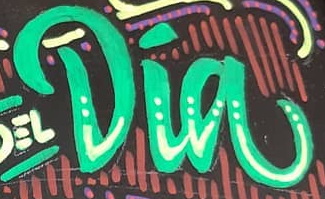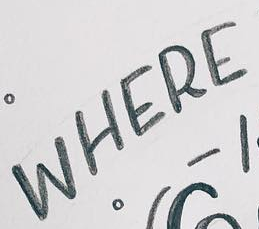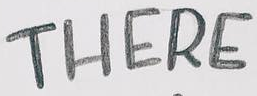What words can you see in these images in sequence, separated by a semicolon? Dia; WHERE; THERE 